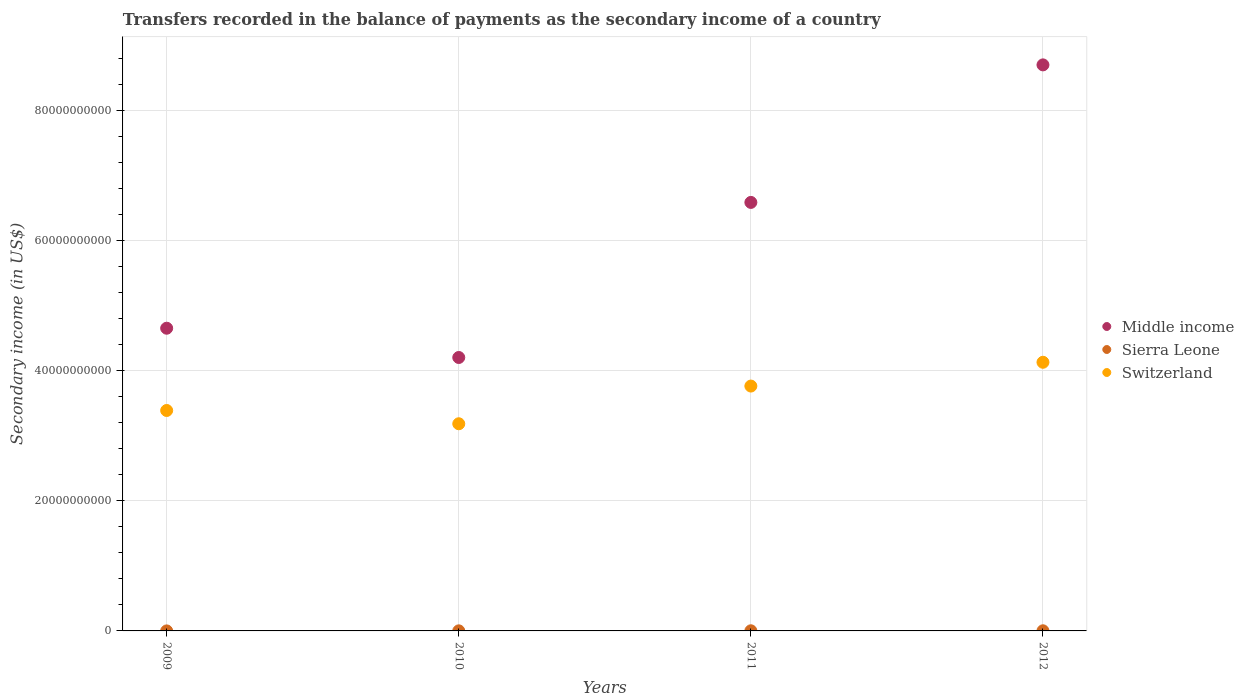How many different coloured dotlines are there?
Your answer should be very brief. 3. Is the number of dotlines equal to the number of legend labels?
Provide a succinct answer. Yes. What is the secondary income of in Switzerland in 2009?
Your answer should be compact. 3.39e+1. Across all years, what is the maximum secondary income of in Sierra Leone?
Ensure brevity in your answer.  2.10e+07. Across all years, what is the minimum secondary income of in Middle income?
Make the answer very short. 4.20e+1. In which year was the secondary income of in Switzerland maximum?
Provide a short and direct response. 2012. In which year was the secondary income of in Switzerland minimum?
Give a very brief answer. 2010. What is the total secondary income of in Middle income in the graph?
Ensure brevity in your answer.  2.41e+11. What is the difference between the secondary income of in Sierra Leone in 2011 and that in 2012?
Give a very brief answer. 7.15e+05. What is the difference between the secondary income of in Switzerland in 2012 and the secondary income of in Middle income in 2009?
Offer a terse response. -5.23e+09. What is the average secondary income of in Middle income per year?
Your answer should be very brief. 6.04e+1. In the year 2010, what is the difference between the secondary income of in Switzerland and secondary income of in Sierra Leone?
Keep it short and to the point. 3.18e+1. What is the ratio of the secondary income of in Sierra Leone in 2009 to that in 2010?
Provide a succinct answer. 0.23. Is the secondary income of in Switzerland in 2010 less than that in 2011?
Make the answer very short. Yes. Is the difference between the secondary income of in Switzerland in 2010 and 2011 greater than the difference between the secondary income of in Sierra Leone in 2010 and 2011?
Provide a short and direct response. No. What is the difference between the highest and the second highest secondary income of in Middle income?
Offer a very short reply. 2.11e+1. What is the difference between the highest and the lowest secondary income of in Middle income?
Your response must be concise. 4.50e+1. In how many years, is the secondary income of in Switzerland greater than the average secondary income of in Switzerland taken over all years?
Give a very brief answer. 2. Is the secondary income of in Switzerland strictly greater than the secondary income of in Sierra Leone over the years?
Your response must be concise. Yes. How many dotlines are there?
Provide a short and direct response. 3. What is the difference between two consecutive major ticks on the Y-axis?
Keep it short and to the point. 2.00e+1. Does the graph contain any zero values?
Ensure brevity in your answer.  No. How are the legend labels stacked?
Your answer should be very brief. Vertical. What is the title of the graph?
Offer a very short reply. Transfers recorded in the balance of payments as the secondary income of a country. What is the label or title of the X-axis?
Your response must be concise. Years. What is the label or title of the Y-axis?
Offer a very short reply. Secondary income (in US$). What is the Secondary income (in US$) in Middle income in 2009?
Offer a terse response. 4.65e+1. What is the Secondary income (in US$) of Sierra Leone in 2009?
Ensure brevity in your answer.  2.72e+06. What is the Secondary income (in US$) of Switzerland in 2009?
Give a very brief answer. 3.39e+1. What is the Secondary income (in US$) of Middle income in 2010?
Ensure brevity in your answer.  4.20e+1. What is the Secondary income (in US$) in Sierra Leone in 2010?
Give a very brief answer. 1.19e+07. What is the Secondary income (in US$) of Switzerland in 2010?
Offer a very short reply. 3.19e+1. What is the Secondary income (in US$) of Middle income in 2011?
Give a very brief answer. 6.59e+1. What is the Secondary income (in US$) in Sierra Leone in 2011?
Keep it short and to the point. 2.10e+07. What is the Secondary income (in US$) of Switzerland in 2011?
Ensure brevity in your answer.  3.76e+1. What is the Secondary income (in US$) of Middle income in 2012?
Give a very brief answer. 8.70e+1. What is the Secondary income (in US$) of Sierra Leone in 2012?
Make the answer very short. 2.03e+07. What is the Secondary income (in US$) in Switzerland in 2012?
Provide a short and direct response. 4.13e+1. Across all years, what is the maximum Secondary income (in US$) in Middle income?
Give a very brief answer. 8.70e+1. Across all years, what is the maximum Secondary income (in US$) in Sierra Leone?
Provide a short and direct response. 2.10e+07. Across all years, what is the maximum Secondary income (in US$) in Switzerland?
Your answer should be very brief. 4.13e+1. Across all years, what is the minimum Secondary income (in US$) in Middle income?
Your answer should be compact. 4.20e+1. Across all years, what is the minimum Secondary income (in US$) of Sierra Leone?
Offer a very short reply. 2.72e+06. Across all years, what is the minimum Secondary income (in US$) of Switzerland?
Offer a very short reply. 3.19e+1. What is the total Secondary income (in US$) in Middle income in the graph?
Provide a short and direct response. 2.41e+11. What is the total Secondary income (in US$) of Sierra Leone in the graph?
Provide a succinct answer. 5.60e+07. What is the total Secondary income (in US$) of Switzerland in the graph?
Provide a short and direct response. 1.45e+11. What is the difference between the Secondary income (in US$) of Middle income in 2009 and that in 2010?
Your response must be concise. 4.50e+09. What is the difference between the Secondary income (in US$) of Sierra Leone in 2009 and that in 2010?
Provide a succinct answer. -9.21e+06. What is the difference between the Secondary income (in US$) in Switzerland in 2009 and that in 2010?
Offer a terse response. 2.04e+09. What is the difference between the Secondary income (in US$) in Middle income in 2009 and that in 2011?
Provide a succinct answer. -1.93e+1. What is the difference between the Secondary income (in US$) of Sierra Leone in 2009 and that in 2011?
Make the answer very short. -1.83e+07. What is the difference between the Secondary income (in US$) in Switzerland in 2009 and that in 2011?
Your answer should be very brief. -3.75e+09. What is the difference between the Secondary income (in US$) in Middle income in 2009 and that in 2012?
Make the answer very short. -4.05e+1. What is the difference between the Secondary income (in US$) of Sierra Leone in 2009 and that in 2012?
Ensure brevity in your answer.  -1.76e+07. What is the difference between the Secondary income (in US$) in Switzerland in 2009 and that in 2012?
Keep it short and to the point. -7.41e+09. What is the difference between the Secondary income (in US$) of Middle income in 2010 and that in 2011?
Your response must be concise. -2.38e+1. What is the difference between the Secondary income (in US$) of Sierra Leone in 2010 and that in 2011?
Provide a short and direct response. -9.09e+06. What is the difference between the Secondary income (in US$) of Switzerland in 2010 and that in 2011?
Provide a short and direct response. -5.80e+09. What is the difference between the Secondary income (in US$) of Middle income in 2010 and that in 2012?
Provide a short and direct response. -4.50e+1. What is the difference between the Secondary income (in US$) in Sierra Leone in 2010 and that in 2012?
Keep it short and to the point. -8.37e+06. What is the difference between the Secondary income (in US$) of Switzerland in 2010 and that in 2012?
Your answer should be very brief. -9.45e+09. What is the difference between the Secondary income (in US$) of Middle income in 2011 and that in 2012?
Keep it short and to the point. -2.11e+1. What is the difference between the Secondary income (in US$) in Sierra Leone in 2011 and that in 2012?
Provide a short and direct response. 7.15e+05. What is the difference between the Secondary income (in US$) in Switzerland in 2011 and that in 2012?
Provide a short and direct response. -3.66e+09. What is the difference between the Secondary income (in US$) in Middle income in 2009 and the Secondary income (in US$) in Sierra Leone in 2010?
Make the answer very short. 4.65e+1. What is the difference between the Secondary income (in US$) in Middle income in 2009 and the Secondary income (in US$) in Switzerland in 2010?
Your answer should be very brief. 1.47e+1. What is the difference between the Secondary income (in US$) in Sierra Leone in 2009 and the Secondary income (in US$) in Switzerland in 2010?
Your response must be concise. -3.18e+1. What is the difference between the Secondary income (in US$) in Middle income in 2009 and the Secondary income (in US$) in Sierra Leone in 2011?
Ensure brevity in your answer.  4.65e+1. What is the difference between the Secondary income (in US$) in Middle income in 2009 and the Secondary income (in US$) in Switzerland in 2011?
Ensure brevity in your answer.  8.89e+09. What is the difference between the Secondary income (in US$) in Sierra Leone in 2009 and the Secondary income (in US$) in Switzerland in 2011?
Your answer should be very brief. -3.76e+1. What is the difference between the Secondary income (in US$) in Middle income in 2009 and the Secondary income (in US$) in Sierra Leone in 2012?
Provide a short and direct response. 4.65e+1. What is the difference between the Secondary income (in US$) of Middle income in 2009 and the Secondary income (in US$) of Switzerland in 2012?
Offer a very short reply. 5.23e+09. What is the difference between the Secondary income (in US$) of Sierra Leone in 2009 and the Secondary income (in US$) of Switzerland in 2012?
Provide a succinct answer. -4.13e+1. What is the difference between the Secondary income (in US$) of Middle income in 2010 and the Secondary income (in US$) of Sierra Leone in 2011?
Offer a very short reply. 4.20e+1. What is the difference between the Secondary income (in US$) of Middle income in 2010 and the Secondary income (in US$) of Switzerland in 2011?
Ensure brevity in your answer.  4.39e+09. What is the difference between the Secondary income (in US$) of Sierra Leone in 2010 and the Secondary income (in US$) of Switzerland in 2011?
Your response must be concise. -3.76e+1. What is the difference between the Secondary income (in US$) of Middle income in 2010 and the Secondary income (in US$) of Sierra Leone in 2012?
Your answer should be compact. 4.20e+1. What is the difference between the Secondary income (in US$) of Middle income in 2010 and the Secondary income (in US$) of Switzerland in 2012?
Offer a very short reply. 7.35e+08. What is the difference between the Secondary income (in US$) in Sierra Leone in 2010 and the Secondary income (in US$) in Switzerland in 2012?
Offer a very short reply. -4.13e+1. What is the difference between the Secondary income (in US$) of Middle income in 2011 and the Secondary income (in US$) of Sierra Leone in 2012?
Offer a very short reply. 6.59e+1. What is the difference between the Secondary income (in US$) in Middle income in 2011 and the Secondary income (in US$) in Switzerland in 2012?
Give a very brief answer. 2.46e+1. What is the difference between the Secondary income (in US$) of Sierra Leone in 2011 and the Secondary income (in US$) of Switzerland in 2012?
Offer a terse response. -4.13e+1. What is the average Secondary income (in US$) in Middle income per year?
Your answer should be very brief. 6.04e+1. What is the average Secondary income (in US$) of Sierra Leone per year?
Provide a succinct answer. 1.40e+07. What is the average Secondary income (in US$) of Switzerland per year?
Keep it short and to the point. 3.62e+1. In the year 2009, what is the difference between the Secondary income (in US$) of Middle income and Secondary income (in US$) of Sierra Leone?
Provide a succinct answer. 4.65e+1. In the year 2009, what is the difference between the Secondary income (in US$) in Middle income and Secondary income (in US$) in Switzerland?
Your answer should be compact. 1.26e+1. In the year 2009, what is the difference between the Secondary income (in US$) in Sierra Leone and Secondary income (in US$) in Switzerland?
Your response must be concise. -3.39e+1. In the year 2010, what is the difference between the Secondary income (in US$) of Middle income and Secondary income (in US$) of Sierra Leone?
Keep it short and to the point. 4.20e+1. In the year 2010, what is the difference between the Secondary income (in US$) of Middle income and Secondary income (in US$) of Switzerland?
Offer a terse response. 1.02e+1. In the year 2010, what is the difference between the Secondary income (in US$) of Sierra Leone and Secondary income (in US$) of Switzerland?
Your answer should be very brief. -3.18e+1. In the year 2011, what is the difference between the Secondary income (in US$) of Middle income and Secondary income (in US$) of Sierra Leone?
Your answer should be very brief. 6.59e+1. In the year 2011, what is the difference between the Secondary income (in US$) of Middle income and Secondary income (in US$) of Switzerland?
Ensure brevity in your answer.  2.82e+1. In the year 2011, what is the difference between the Secondary income (in US$) of Sierra Leone and Secondary income (in US$) of Switzerland?
Offer a very short reply. -3.76e+1. In the year 2012, what is the difference between the Secondary income (in US$) in Middle income and Secondary income (in US$) in Sierra Leone?
Ensure brevity in your answer.  8.70e+1. In the year 2012, what is the difference between the Secondary income (in US$) in Middle income and Secondary income (in US$) in Switzerland?
Keep it short and to the point. 4.57e+1. In the year 2012, what is the difference between the Secondary income (in US$) of Sierra Leone and Secondary income (in US$) of Switzerland?
Make the answer very short. -4.13e+1. What is the ratio of the Secondary income (in US$) in Middle income in 2009 to that in 2010?
Ensure brevity in your answer.  1.11. What is the ratio of the Secondary income (in US$) of Sierra Leone in 2009 to that in 2010?
Offer a terse response. 0.23. What is the ratio of the Secondary income (in US$) of Switzerland in 2009 to that in 2010?
Give a very brief answer. 1.06. What is the ratio of the Secondary income (in US$) in Middle income in 2009 to that in 2011?
Ensure brevity in your answer.  0.71. What is the ratio of the Secondary income (in US$) of Sierra Leone in 2009 to that in 2011?
Offer a very short reply. 0.13. What is the ratio of the Secondary income (in US$) of Switzerland in 2009 to that in 2011?
Your answer should be very brief. 0.9. What is the ratio of the Secondary income (in US$) in Middle income in 2009 to that in 2012?
Offer a terse response. 0.53. What is the ratio of the Secondary income (in US$) of Sierra Leone in 2009 to that in 2012?
Keep it short and to the point. 0.13. What is the ratio of the Secondary income (in US$) of Switzerland in 2009 to that in 2012?
Offer a very short reply. 0.82. What is the ratio of the Secondary income (in US$) of Middle income in 2010 to that in 2011?
Provide a short and direct response. 0.64. What is the ratio of the Secondary income (in US$) of Sierra Leone in 2010 to that in 2011?
Your answer should be compact. 0.57. What is the ratio of the Secondary income (in US$) of Switzerland in 2010 to that in 2011?
Make the answer very short. 0.85. What is the ratio of the Secondary income (in US$) of Middle income in 2010 to that in 2012?
Make the answer very short. 0.48. What is the ratio of the Secondary income (in US$) in Sierra Leone in 2010 to that in 2012?
Your answer should be compact. 0.59. What is the ratio of the Secondary income (in US$) of Switzerland in 2010 to that in 2012?
Keep it short and to the point. 0.77. What is the ratio of the Secondary income (in US$) of Middle income in 2011 to that in 2012?
Your response must be concise. 0.76. What is the ratio of the Secondary income (in US$) in Sierra Leone in 2011 to that in 2012?
Provide a succinct answer. 1.04. What is the ratio of the Secondary income (in US$) in Switzerland in 2011 to that in 2012?
Provide a succinct answer. 0.91. What is the difference between the highest and the second highest Secondary income (in US$) in Middle income?
Keep it short and to the point. 2.11e+1. What is the difference between the highest and the second highest Secondary income (in US$) of Sierra Leone?
Keep it short and to the point. 7.15e+05. What is the difference between the highest and the second highest Secondary income (in US$) of Switzerland?
Your answer should be very brief. 3.66e+09. What is the difference between the highest and the lowest Secondary income (in US$) of Middle income?
Give a very brief answer. 4.50e+1. What is the difference between the highest and the lowest Secondary income (in US$) of Sierra Leone?
Offer a very short reply. 1.83e+07. What is the difference between the highest and the lowest Secondary income (in US$) of Switzerland?
Offer a terse response. 9.45e+09. 